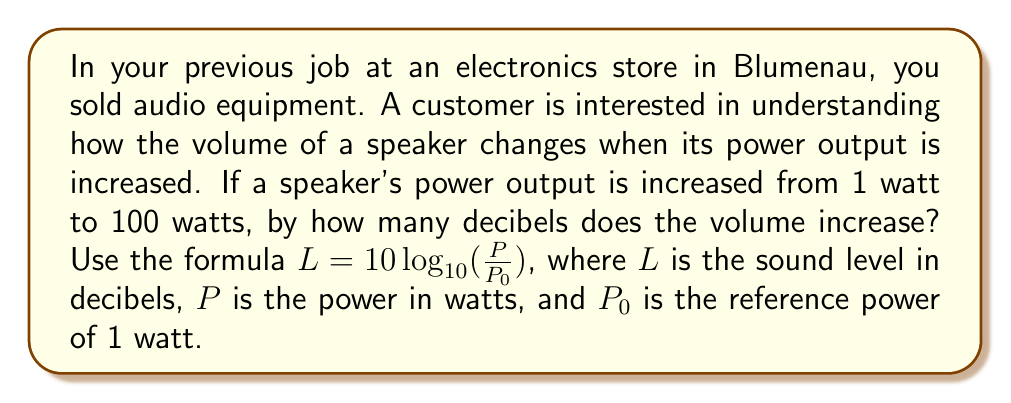Can you solve this math problem? Let's approach this step-by-step:

1) We're using the formula $L = 10 \log_{10}(\frac{P}{P_0})$

2) We need to calculate the difference between two sound levels:
   $L_2 - L_1 = 10 \log_{10}(\frac{P_2}{P_0}) - 10 \log_{10}(\frac{P_1}{P_0})$

3) $P_1 = 1$ watt (initial power)
   $P_2 = 100$ watts (final power)
   $P_0 = 1$ watt (reference power)

4) Substituting these values:
   $L_2 - L_1 = 10 \log_{10}(\frac{100}{1}) - 10 \log_{10}(\frac{1}{1})$

5) Simplify:
   $L_2 - L_1 = 10 \log_{10}(100) - 10 \log_{10}(1)$

6) $\log_{10}(1) = 0$, so:
   $L_2 - L_1 = 10 \log_{10}(100) - 0 = 10 \log_{10}(100)$

7) $\log_{10}(100) = 2$, so:
   $L_2 - L_1 = 10 \cdot 2 = 20$

Therefore, the volume increases by 20 decibels.
Answer: 20 dB 